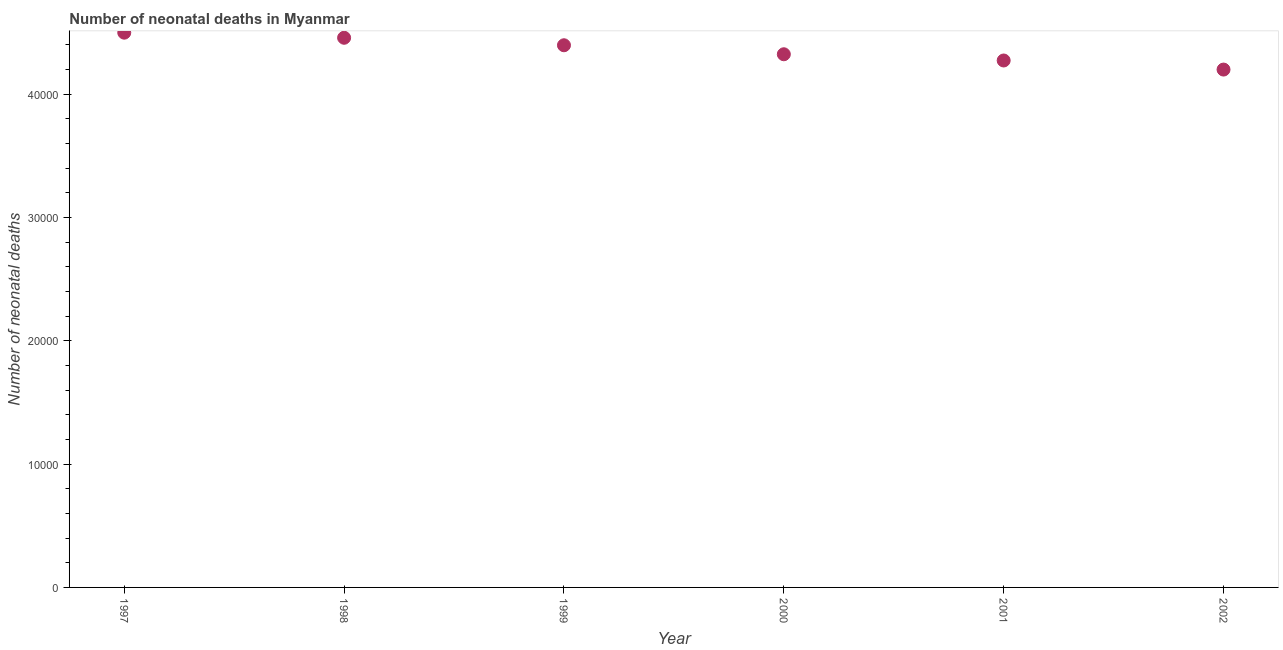What is the number of neonatal deaths in 2002?
Offer a very short reply. 4.20e+04. Across all years, what is the maximum number of neonatal deaths?
Your answer should be very brief. 4.50e+04. Across all years, what is the minimum number of neonatal deaths?
Provide a short and direct response. 4.20e+04. In which year was the number of neonatal deaths minimum?
Provide a short and direct response. 2002. What is the sum of the number of neonatal deaths?
Keep it short and to the point. 2.61e+05. What is the difference between the number of neonatal deaths in 1997 and 2002?
Offer a very short reply. 2992. What is the average number of neonatal deaths per year?
Provide a succinct answer. 4.36e+04. What is the median number of neonatal deaths?
Your answer should be compact. 4.36e+04. Do a majority of the years between 1999 and 2000 (inclusive) have number of neonatal deaths greater than 2000 ?
Your response must be concise. Yes. What is the ratio of the number of neonatal deaths in 1997 to that in 2001?
Provide a succinct answer. 1.05. Is the difference between the number of neonatal deaths in 2001 and 2002 greater than the difference between any two years?
Provide a succinct answer. No. What is the difference between the highest and the second highest number of neonatal deaths?
Ensure brevity in your answer.  414. What is the difference between the highest and the lowest number of neonatal deaths?
Your response must be concise. 2992. Does the number of neonatal deaths monotonically increase over the years?
Provide a short and direct response. No. How many dotlines are there?
Your answer should be compact. 1. What is the title of the graph?
Offer a very short reply. Number of neonatal deaths in Myanmar. What is the label or title of the Y-axis?
Make the answer very short. Number of neonatal deaths. What is the Number of neonatal deaths in 1997?
Make the answer very short. 4.50e+04. What is the Number of neonatal deaths in 1998?
Your answer should be very brief. 4.46e+04. What is the Number of neonatal deaths in 1999?
Your answer should be compact. 4.40e+04. What is the Number of neonatal deaths in 2000?
Your answer should be compact. 4.32e+04. What is the Number of neonatal deaths in 2001?
Offer a terse response. 4.27e+04. What is the Number of neonatal deaths in 2002?
Your answer should be compact. 4.20e+04. What is the difference between the Number of neonatal deaths in 1997 and 1998?
Ensure brevity in your answer.  414. What is the difference between the Number of neonatal deaths in 1997 and 1999?
Ensure brevity in your answer.  1021. What is the difference between the Number of neonatal deaths in 1997 and 2000?
Your answer should be compact. 1751. What is the difference between the Number of neonatal deaths in 1997 and 2001?
Your answer should be compact. 2256. What is the difference between the Number of neonatal deaths in 1997 and 2002?
Keep it short and to the point. 2992. What is the difference between the Number of neonatal deaths in 1998 and 1999?
Your answer should be compact. 607. What is the difference between the Number of neonatal deaths in 1998 and 2000?
Your answer should be compact. 1337. What is the difference between the Number of neonatal deaths in 1998 and 2001?
Give a very brief answer. 1842. What is the difference between the Number of neonatal deaths in 1998 and 2002?
Your answer should be very brief. 2578. What is the difference between the Number of neonatal deaths in 1999 and 2000?
Keep it short and to the point. 730. What is the difference between the Number of neonatal deaths in 1999 and 2001?
Provide a succinct answer. 1235. What is the difference between the Number of neonatal deaths in 1999 and 2002?
Your answer should be very brief. 1971. What is the difference between the Number of neonatal deaths in 2000 and 2001?
Provide a succinct answer. 505. What is the difference between the Number of neonatal deaths in 2000 and 2002?
Keep it short and to the point. 1241. What is the difference between the Number of neonatal deaths in 2001 and 2002?
Offer a terse response. 736. What is the ratio of the Number of neonatal deaths in 1997 to that in 1999?
Provide a succinct answer. 1.02. What is the ratio of the Number of neonatal deaths in 1997 to that in 2000?
Offer a very short reply. 1.04. What is the ratio of the Number of neonatal deaths in 1997 to that in 2001?
Give a very brief answer. 1.05. What is the ratio of the Number of neonatal deaths in 1997 to that in 2002?
Offer a terse response. 1.07. What is the ratio of the Number of neonatal deaths in 1998 to that in 2000?
Your answer should be very brief. 1.03. What is the ratio of the Number of neonatal deaths in 1998 to that in 2001?
Ensure brevity in your answer.  1.04. What is the ratio of the Number of neonatal deaths in 1998 to that in 2002?
Make the answer very short. 1.06. What is the ratio of the Number of neonatal deaths in 1999 to that in 2000?
Provide a short and direct response. 1.02. What is the ratio of the Number of neonatal deaths in 1999 to that in 2001?
Your answer should be very brief. 1.03. What is the ratio of the Number of neonatal deaths in 1999 to that in 2002?
Your answer should be compact. 1.05. What is the ratio of the Number of neonatal deaths in 2000 to that in 2002?
Your answer should be compact. 1.03. What is the ratio of the Number of neonatal deaths in 2001 to that in 2002?
Offer a very short reply. 1.02. 